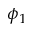Convert formula to latex. <formula><loc_0><loc_0><loc_500><loc_500>\phi _ { 1 }</formula> 